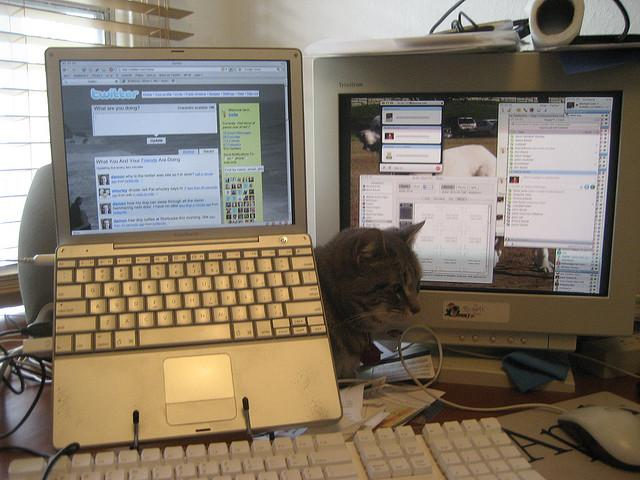What is the cat hiding behind? laptop 